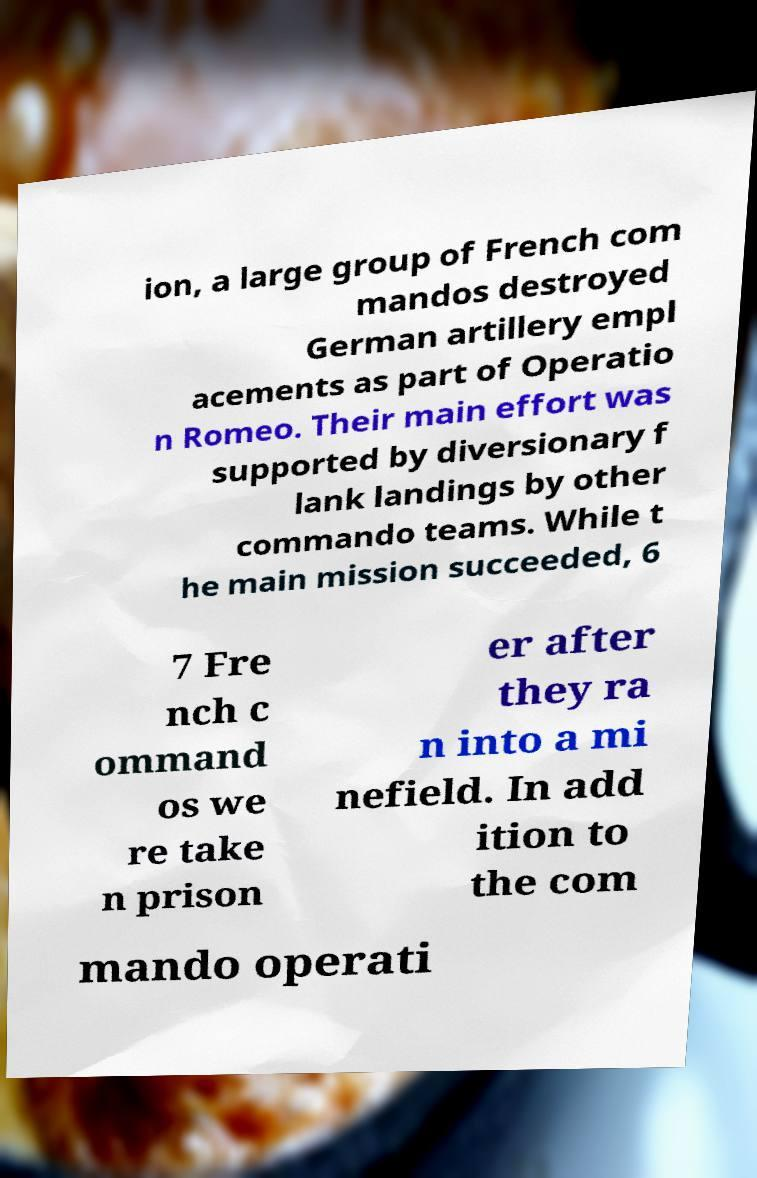Can you accurately transcribe the text from the provided image for me? ion, a large group of French com mandos destroyed German artillery empl acements as part of Operatio n Romeo. Their main effort was supported by diversionary f lank landings by other commando teams. While t he main mission succeeded, 6 7 Fre nch c ommand os we re take n prison er after they ra n into a mi nefield. In add ition to the com mando operati 